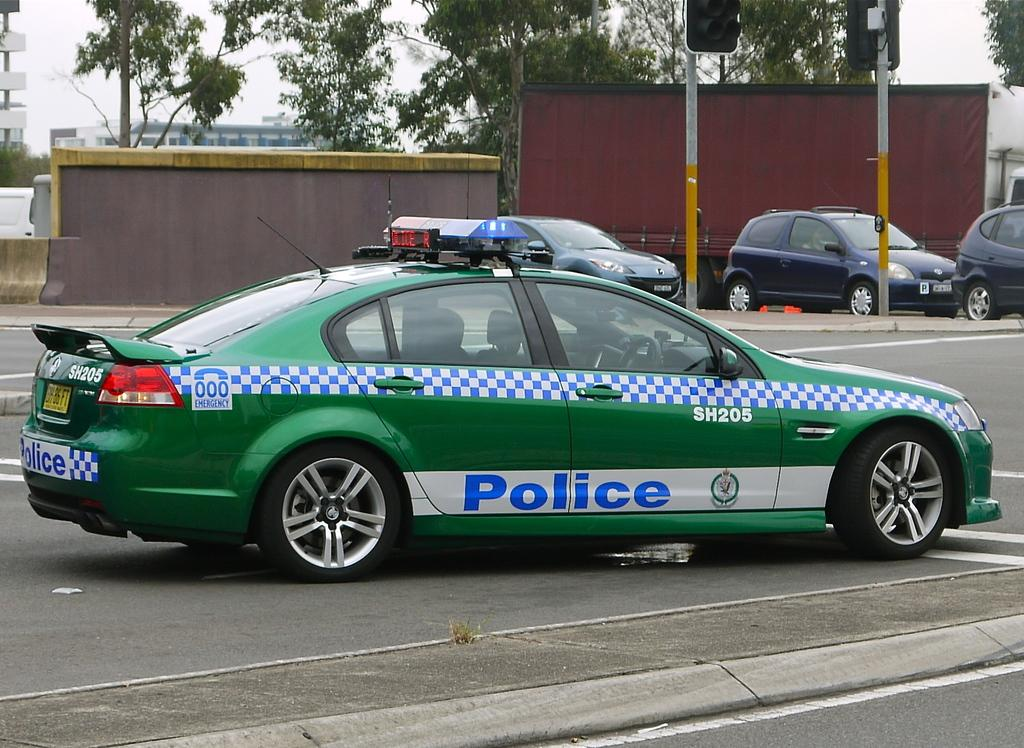Provide a one-sentence caption for the provided image. a car that has the word police on it. 